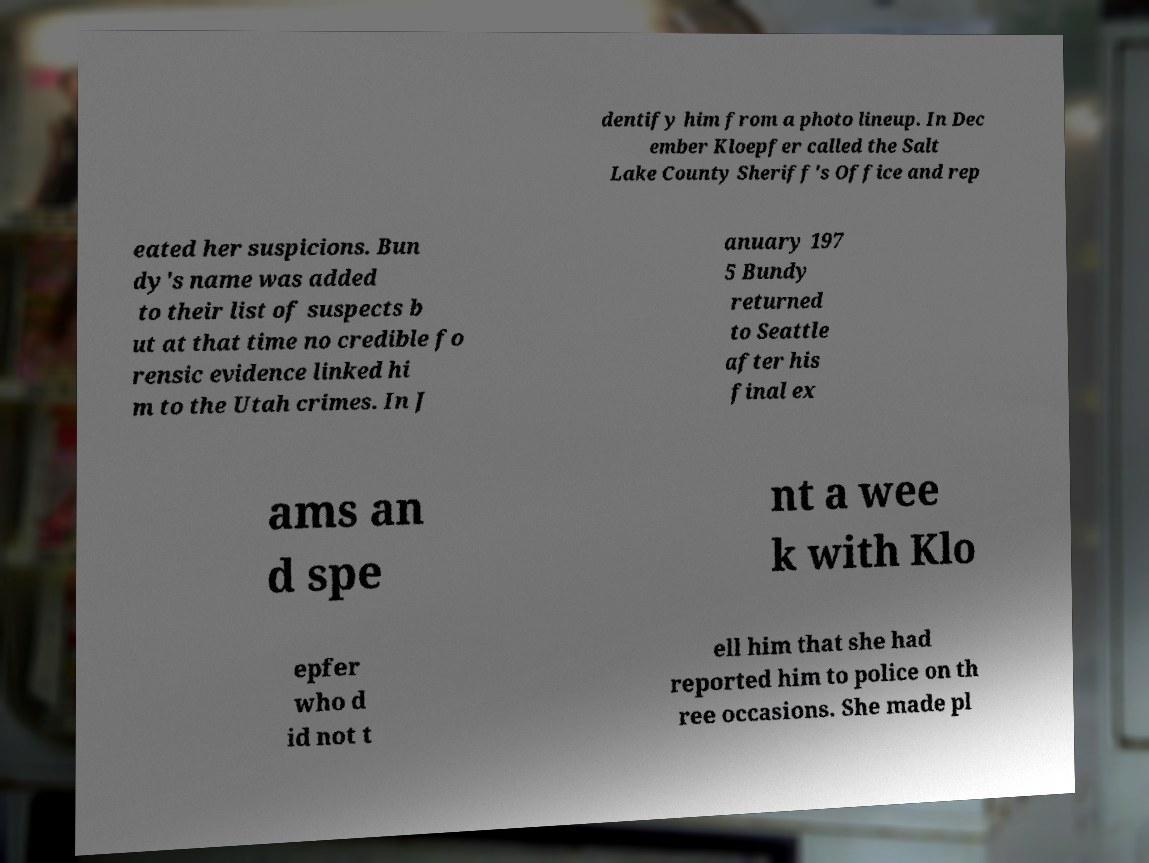Please read and relay the text visible in this image. What does it say? dentify him from a photo lineup. In Dec ember Kloepfer called the Salt Lake County Sheriff's Office and rep eated her suspicions. Bun dy's name was added to their list of suspects b ut at that time no credible fo rensic evidence linked hi m to the Utah crimes. In J anuary 197 5 Bundy returned to Seattle after his final ex ams an d spe nt a wee k with Klo epfer who d id not t ell him that she had reported him to police on th ree occasions. She made pl 